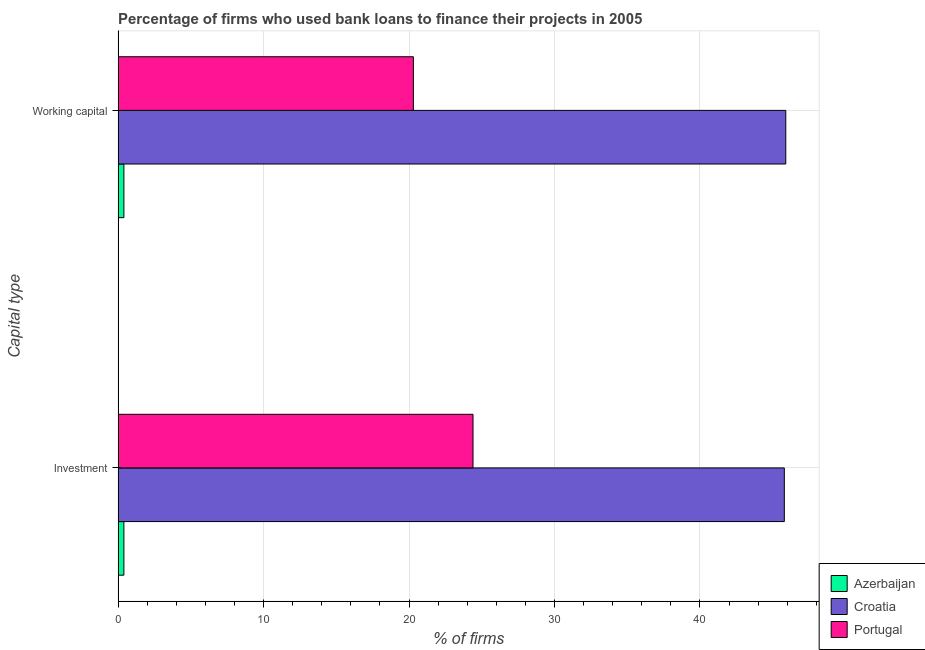Are the number of bars per tick equal to the number of legend labels?
Your answer should be compact. Yes. How many bars are there on the 2nd tick from the top?
Make the answer very short. 3. What is the label of the 1st group of bars from the top?
Your answer should be very brief. Working capital. What is the percentage of firms using banks to finance investment in Portugal?
Keep it short and to the point. 24.4. Across all countries, what is the maximum percentage of firms using banks to finance working capital?
Provide a succinct answer. 45.9. In which country was the percentage of firms using banks to finance investment maximum?
Ensure brevity in your answer.  Croatia. In which country was the percentage of firms using banks to finance investment minimum?
Ensure brevity in your answer.  Azerbaijan. What is the total percentage of firms using banks to finance investment in the graph?
Your answer should be compact. 70.6. What is the difference between the percentage of firms using banks to finance working capital in Azerbaijan and that in Portugal?
Your response must be concise. -19.9. What is the difference between the percentage of firms using banks to finance working capital in Croatia and the percentage of firms using banks to finance investment in Azerbaijan?
Your response must be concise. 45.5. What is the ratio of the percentage of firms using banks to finance investment in Portugal to that in Azerbaijan?
Give a very brief answer. 61. What does the 2nd bar from the top in Investment represents?
Offer a very short reply. Croatia. Are the values on the major ticks of X-axis written in scientific E-notation?
Offer a very short reply. No. Does the graph contain grids?
Your answer should be very brief. Yes. What is the title of the graph?
Your response must be concise. Percentage of firms who used bank loans to finance their projects in 2005. What is the label or title of the X-axis?
Your response must be concise. % of firms. What is the label or title of the Y-axis?
Your response must be concise. Capital type. What is the % of firms in Azerbaijan in Investment?
Provide a succinct answer. 0.4. What is the % of firms in Croatia in Investment?
Make the answer very short. 45.8. What is the % of firms in Portugal in Investment?
Your answer should be compact. 24.4. What is the % of firms in Croatia in Working capital?
Make the answer very short. 45.9. What is the % of firms in Portugal in Working capital?
Keep it short and to the point. 20.3. Across all Capital type, what is the maximum % of firms of Croatia?
Your response must be concise. 45.9. Across all Capital type, what is the maximum % of firms in Portugal?
Offer a terse response. 24.4. Across all Capital type, what is the minimum % of firms in Azerbaijan?
Your answer should be very brief. 0.4. Across all Capital type, what is the minimum % of firms of Croatia?
Your response must be concise. 45.8. Across all Capital type, what is the minimum % of firms in Portugal?
Provide a short and direct response. 20.3. What is the total % of firms in Croatia in the graph?
Offer a very short reply. 91.7. What is the total % of firms in Portugal in the graph?
Ensure brevity in your answer.  44.7. What is the difference between the % of firms in Azerbaijan in Investment and that in Working capital?
Keep it short and to the point. 0. What is the difference between the % of firms in Azerbaijan in Investment and the % of firms in Croatia in Working capital?
Offer a terse response. -45.5. What is the difference between the % of firms in Azerbaijan in Investment and the % of firms in Portugal in Working capital?
Make the answer very short. -19.9. What is the average % of firms of Azerbaijan per Capital type?
Make the answer very short. 0.4. What is the average % of firms in Croatia per Capital type?
Provide a short and direct response. 45.85. What is the average % of firms in Portugal per Capital type?
Provide a short and direct response. 22.35. What is the difference between the % of firms in Azerbaijan and % of firms in Croatia in Investment?
Keep it short and to the point. -45.4. What is the difference between the % of firms in Azerbaijan and % of firms in Portugal in Investment?
Your response must be concise. -24. What is the difference between the % of firms of Croatia and % of firms of Portugal in Investment?
Your answer should be compact. 21.4. What is the difference between the % of firms in Azerbaijan and % of firms in Croatia in Working capital?
Your answer should be very brief. -45.5. What is the difference between the % of firms in Azerbaijan and % of firms in Portugal in Working capital?
Offer a terse response. -19.9. What is the difference between the % of firms in Croatia and % of firms in Portugal in Working capital?
Offer a very short reply. 25.6. What is the ratio of the % of firms in Croatia in Investment to that in Working capital?
Provide a succinct answer. 1. What is the ratio of the % of firms in Portugal in Investment to that in Working capital?
Your answer should be compact. 1.2. What is the difference between the highest and the second highest % of firms of Azerbaijan?
Your answer should be compact. 0. What is the difference between the highest and the second highest % of firms of Portugal?
Your response must be concise. 4.1. What is the difference between the highest and the lowest % of firms in Croatia?
Ensure brevity in your answer.  0.1. 